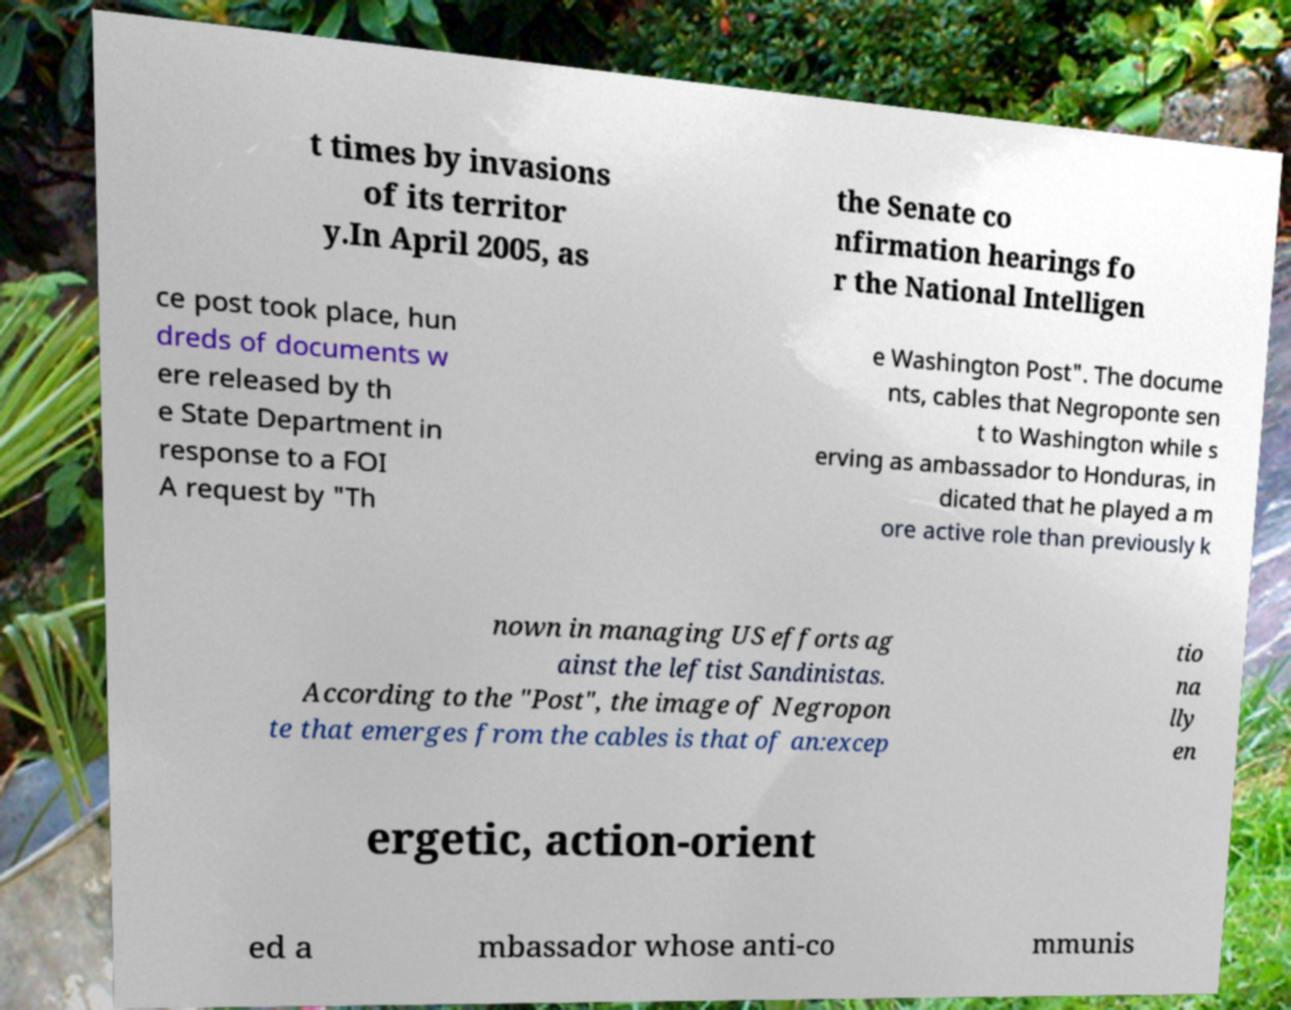Can you read and provide the text displayed in the image?This photo seems to have some interesting text. Can you extract and type it out for me? t times by invasions of its territor y.In April 2005, as the Senate co nfirmation hearings fo r the National Intelligen ce post took place, hun dreds of documents w ere released by th e State Department in response to a FOI A request by "Th e Washington Post". The docume nts, cables that Negroponte sen t to Washington while s erving as ambassador to Honduras, in dicated that he played a m ore active role than previously k nown in managing US efforts ag ainst the leftist Sandinistas. According to the "Post", the image of Negropon te that emerges from the cables is that of an:excep tio na lly en ergetic, action-orient ed a mbassador whose anti-co mmunis 